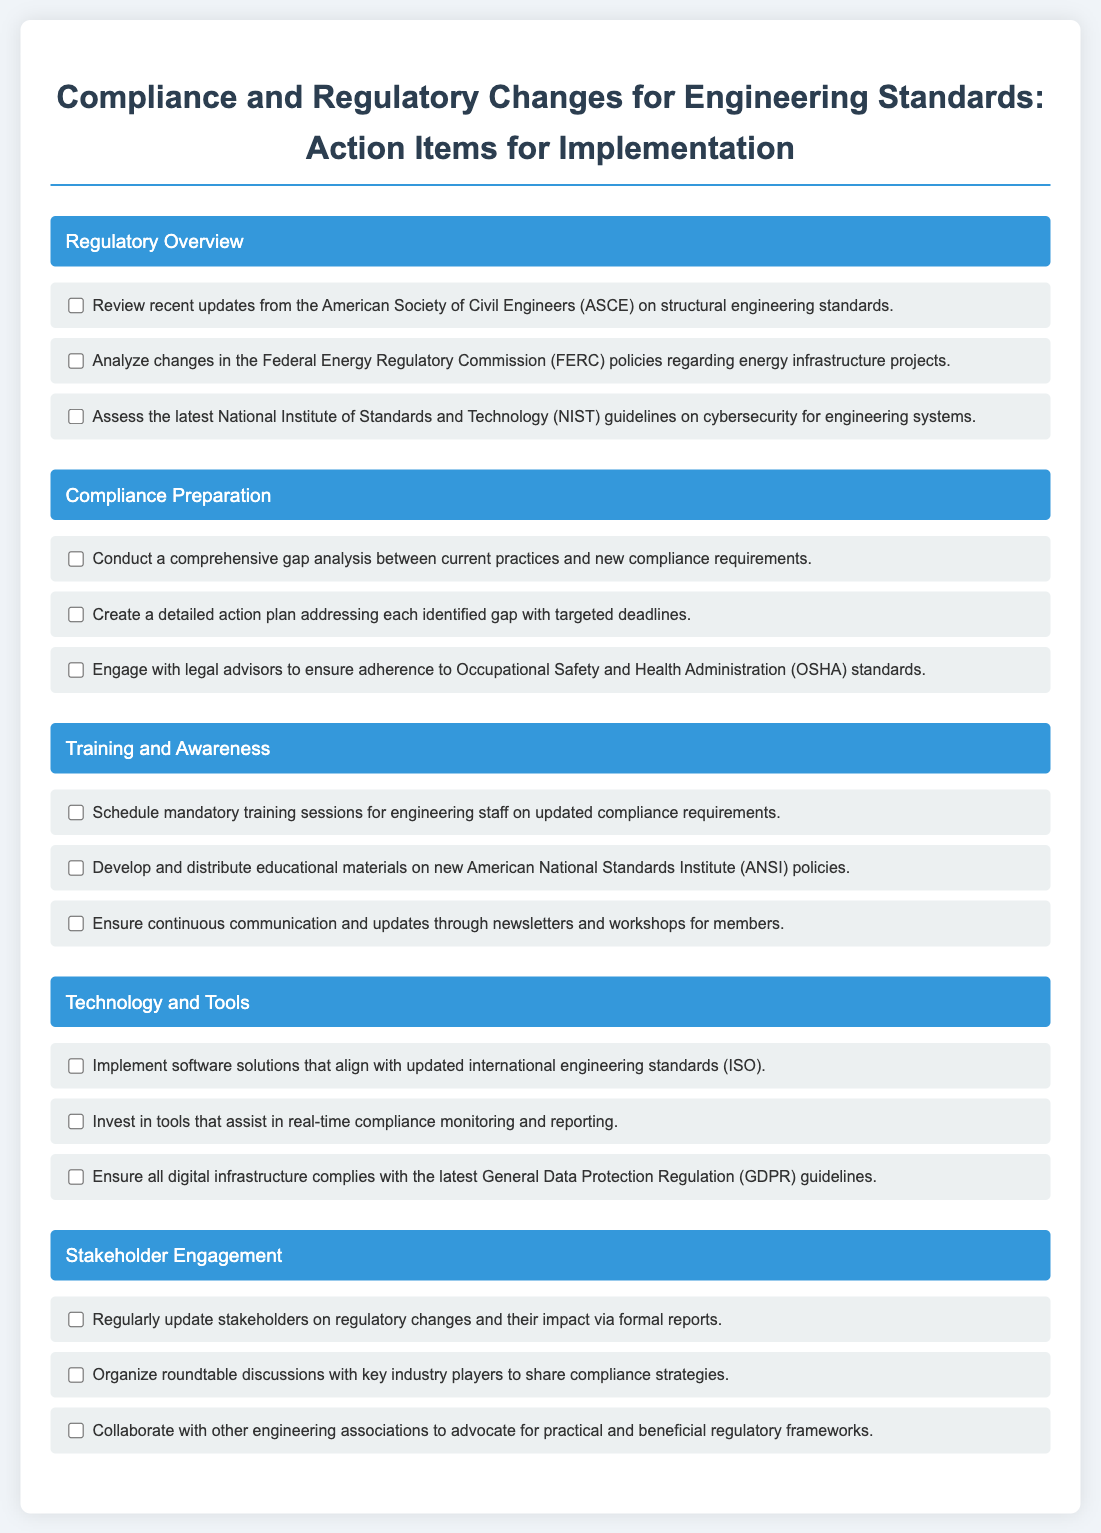what is the first section header in the document? The first section header is "Regulatory Overview" which is the title of the first section of the checklist.
Answer: Regulatory Overview how many action items are listed under "Compliance Preparation"? There are three action items listed under the "Compliance Preparation" section of the checklist.
Answer: 3 what organization is referenced in assessing cybersecurity guidelines? The organization referenced is the National Institute of Standards and Technology.
Answer: National Institute of Standards and Technology what is one specific item mentioned under "Training and Awareness"? One specific item mentioned is scheduling mandatory training sessions for engineering staff on updated compliance requirements.
Answer: Schedule mandatory training sessions how many sections are there in the document? There are five sections in the document, as outlined in the checklist.
Answer: 5 what document is mentioned in relation to stakeholder engagement? The document mentioned is formal reports that update stakeholders on regulatory changes.
Answer: formal reports which regulatory body's updates are to be reviewed in the first section? The regulatory body to review updates from is the American Society of Civil Engineers.
Answer: American Society of Civil Engineers what type of sessions are scheduled for engineering staff according to the checklist? The sessions scheduled for engineering staff are mandatory training sessions on updated compliance requirements.
Answer: mandatory training sessions what is the focus of the "Technology and Tools" section? The focus of the "Technology and Tools" section is on implementing software solutions and investing in tools for compliance monitoring.
Answer: Implement software solutions and invest in tools for compliance monitoring 